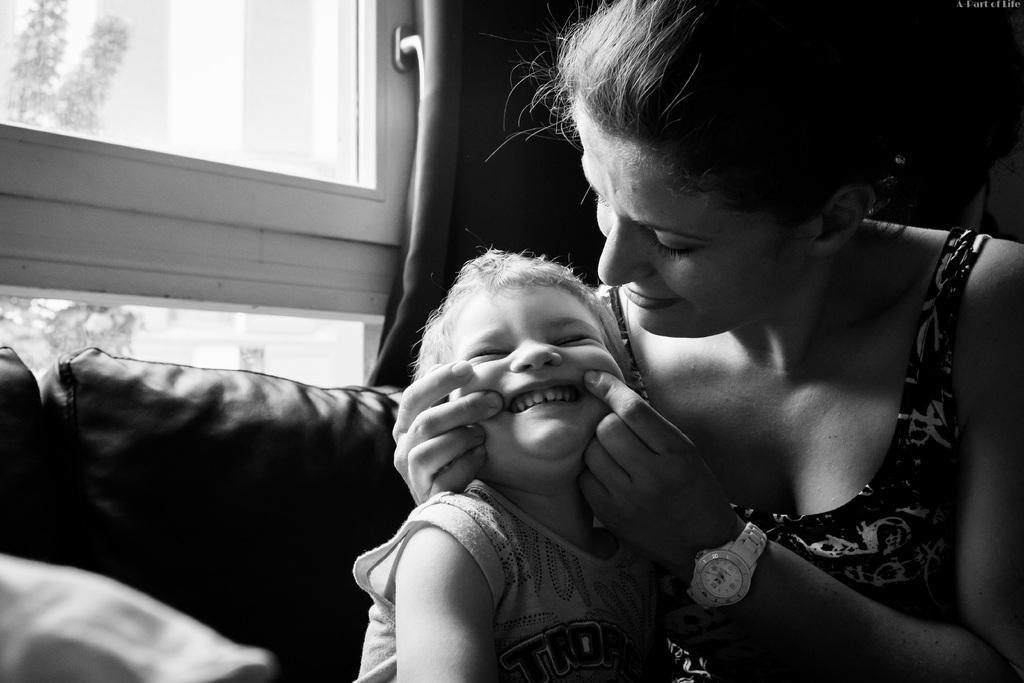Describe this image in one or two sentences. This is a black and white pic. On the right side a woman is pinching the cheeks of a kid who is beside her. On the left side we can see pillows, window glass doors and a curtain. Through the window glass doors we can see trees. 